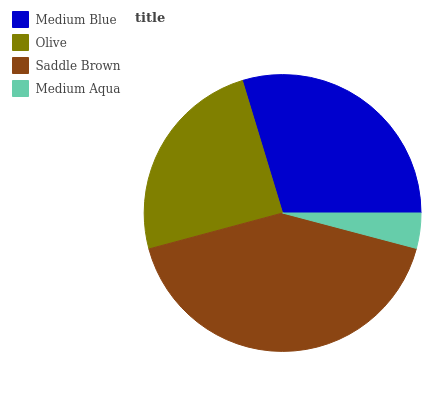Is Medium Aqua the minimum?
Answer yes or no. Yes. Is Saddle Brown the maximum?
Answer yes or no. Yes. Is Olive the minimum?
Answer yes or no. No. Is Olive the maximum?
Answer yes or no. No. Is Medium Blue greater than Olive?
Answer yes or no. Yes. Is Olive less than Medium Blue?
Answer yes or no. Yes. Is Olive greater than Medium Blue?
Answer yes or no. No. Is Medium Blue less than Olive?
Answer yes or no. No. Is Medium Blue the high median?
Answer yes or no. Yes. Is Olive the low median?
Answer yes or no. Yes. Is Olive the high median?
Answer yes or no. No. Is Medium Aqua the low median?
Answer yes or no. No. 